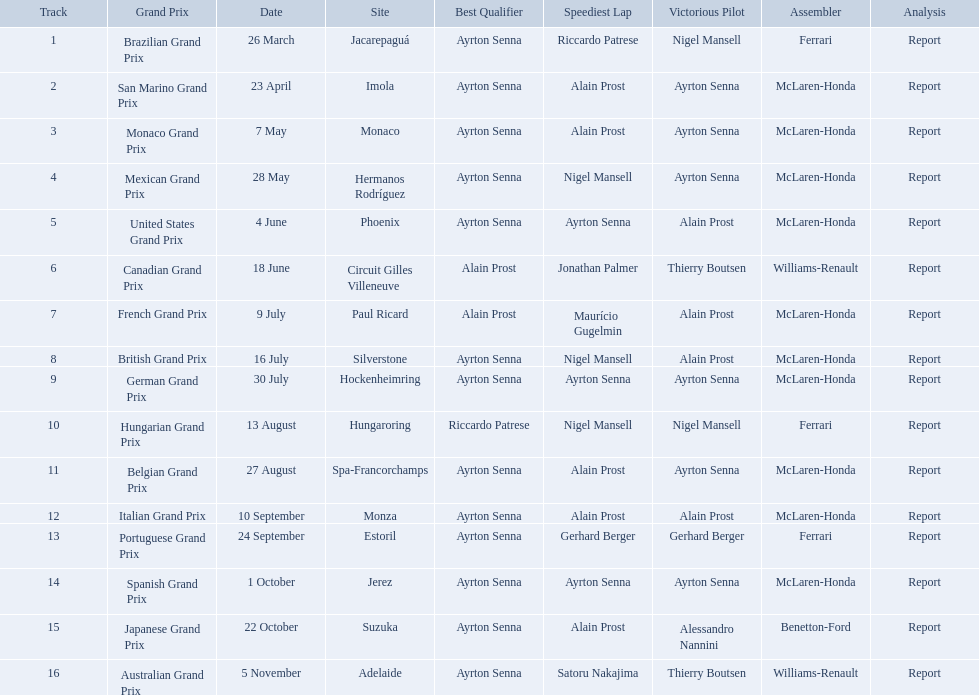Who are the constructors in the 1989 formula one season? Ferrari, McLaren-Honda, McLaren-Honda, McLaren-Honda, McLaren-Honda, Williams-Renault, McLaren-Honda, McLaren-Honda, McLaren-Honda, Ferrari, McLaren-Honda, McLaren-Honda, Ferrari, McLaren-Honda, Benetton-Ford, Williams-Renault. On what date was bennington ford the constructor? 22 October. What was the race on october 22? Japanese Grand Prix. Who won the spanish grand prix? McLaren-Honda. Who won the italian grand prix? McLaren-Honda. What grand prix did benneton-ford win? Japanese Grand Prix. Give me the full table as a dictionary. {'header': ['Track', 'Grand Prix', 'Date', 'Site', 'Best Qualifier', 'Speediest Lap', 'Victorious Pilot', 'Assembler', 'Analysis'], 'rows': [['1', 'Brazilian Grand Prix', '26 March', 'Jacarepaguá', 'Ayrton Senna', 'Riccardo Patrese', 'Nigel Mansell', 'Ferrari', 'Report'], ['2', 'San Marino Grand Prix', '23 April', 'Imola', 'Ayrton Senna', 'Alain Prost', 'Ayrton Senna', 'McLaren-Honda', 'Report'], ['3', 'Monaco Grand Prix', '7 May', 'Monaco', 'Ayrton Senna', 'Alain Prost', 'Ayrton Senna', 'McLaren-Honda', 'Report'], ['4', 'Mexican Grand Prix', '28 May', 'Hermanos Rodríguez', 'Ayrton Senna', 'Nigel Mansell', 'Ayrton Senna', 'McLaren-Honda', 'Report'], ['5', 'United States Grand Prix', '4 June', 'Phoenix', 'Ayrton Senna', 'Ayrton Senna', 'Alain Prost', 'McLaren-Honda', 'Report'], ['6', 'Canadian Grand Prix', '18 June', 'Circuit Gilles Villeneuve', 'Alain Prost', 'Jonathan Palmer', 'Thierry Boutsen', 'Williams-Renault', 'Report'], ['7', 'French Grand Prix', '9 July', 'Paul Ricard', 'Alain Prost', 'Maurício Gugelmin', 'Alain Prost', 'McLaren-Honda', 'Report'], ['8', 'British Grand Prix', '16 July', 'Silverstone', 'Ayrton Senna', 'Nigel Mansell', 'Alain Prost', 'McLaren-Honda', 'Report'], ['9', 'German Grand Prix', '30 July', 'Hockenheimring', 'Ayrton Senna', 'Ayrton Senna', 'Ayrton Senna', 'McLaren-Honda', 'Report'], ['10', 'Hungarian Grand Prix', '13 August', 'Hungaroring', 'Riccardo Patrese', 'Nigel Mansell', 'Nigel Mansell', 'Ferrari', 'Report'], ['11', 'Belgian Grand Prix', '27 August', 'Spa-Francorchamps', 'Ayrton Senna', 'Alain Prost', 'Ayrton Senna', 'McLaren-Honda', 'Report'], ['12', 'Italian Grand Prix', '10 September', 'Monza', 'Ayrton Senna', 'Alain Prost', 'Alain Prost', 'McLaren-Honda', 'Report'], ['13', 'Portuguese Grand Prix', '24 September', 'Estoril', 'Ayrton Senna', 'Gerhard Berger', 'Gerhard Berger', 'Ferrari', 'Report'], ['14', 'Spanish Grand Prix', '1 October', 'Jerez', 'Ayrton Senna', 'Ayrton Senna', 'Ayrton Senna', 'McLaren-Honda', 'Report'], ['15', 'Japanese Grand Prix', '22 October', 'Suzuka', 'Ayrton Senna', 'Alain Prost', 'Alessandro Nannini', 'Benetton-Ford', 'Report'], ['16', 'Australian Grand Prix', '5 November', 'Adelaide', 'Ayrton Senna', 'Satoru Nakajima', 'Thierry Boutsen', 'Williams-Renault', 'Report']]} What are all of the grand prix run in the 1989 formula one season? Brazilian Grand Prix, San Marino Grand Prix, Monaco Grand Prix, Mexican Grand Prix, United States Grand Prix, Canadian Grand Prix, French Grand Prix, British Grand Prix, German Grand Prix, Hungarian Grand Prix, Belgian Grand Prix, Italian Grand Prix, Portuguese Grand Prix, Spanish Grand Prix, Japanese Grand Prix, Australian Grand Prix. Of those 1989 formula one grand prix, which were run in october? Spanish Grand Prix, Japanese Grand Prix, Australian Grand Prix. Of those 1989 formula one grand prix run in october, which was the only one to be won by benetton-ford? Japanese Grand Prix. 